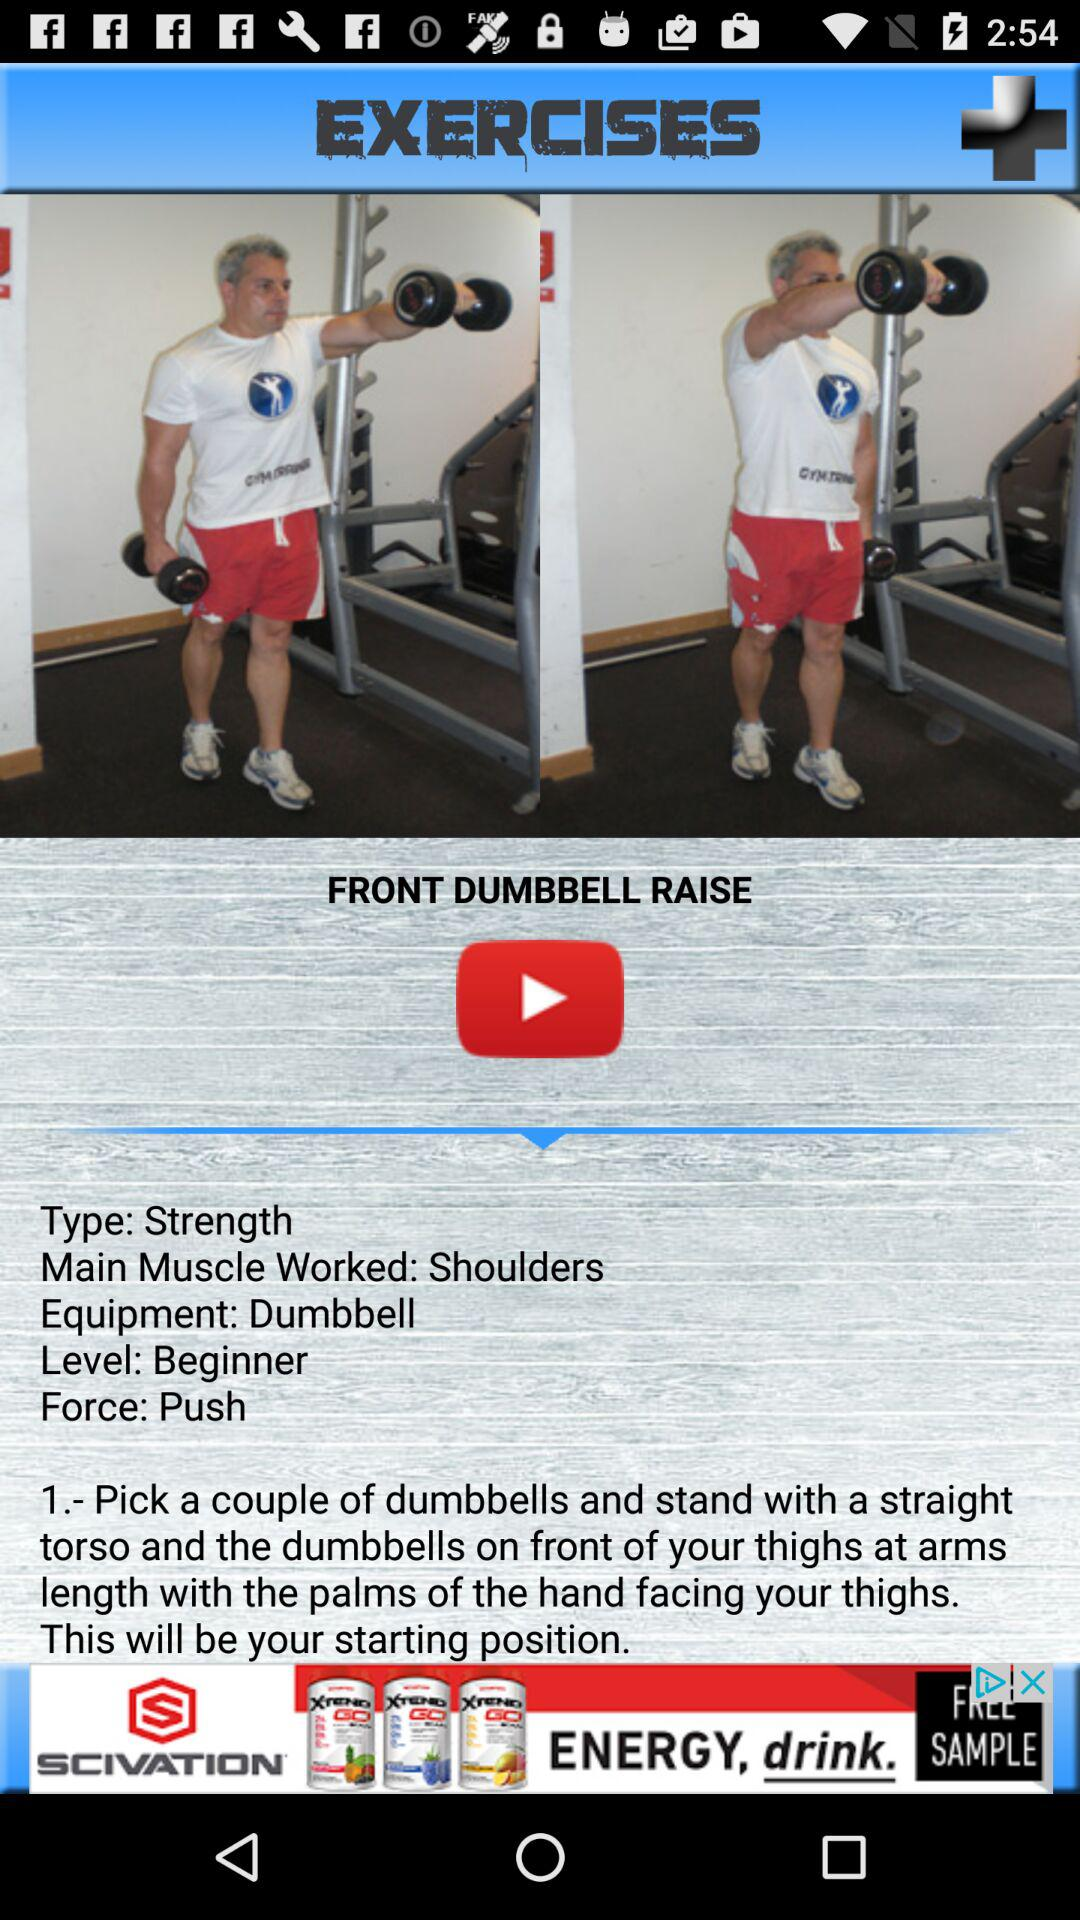What is the level? The level is "Beginner". 